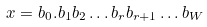<formula> <loc_0><loc_0><loc_500><loc_500>x = b _ { 0 } . b _ { 1 } b _ { 2 } \dots b _ { r } b _ { r + 1 } \dots b _ { W } \\</formula> 